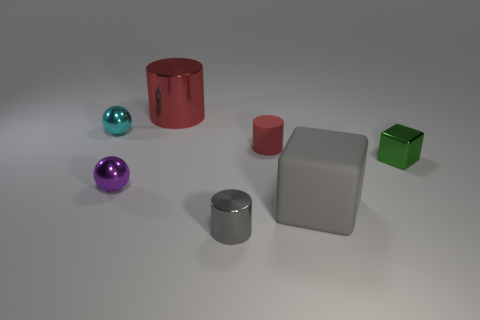There is a cube that is the same material as the small red cylinder; what size is it?
Provide a short and direct response. Large. Do the red metallic cylinder and the gray cylinder have the same size?
Your answer should be very brief. No. Are any cyan metal balls visible?
Offer a very short reply. Yes. There is another thing that is the same color as the small rubber object; what size is it?
Provide a short and direct response. Large. There is a cylinder behind the cyan shiny object that is left of the metal cylinder that is behind the green shiny cube; how big is it?
Ensure brevity in your answer.  Large. What number of small green objects have the same material as the big red object?
Ensure brevity in your answer.  1. What number of gray shiny cylinders are the same size as the cyan object?
Your response must be concise. 1. There is a large gray cube in front of the tiny cyan sphere left of the small object to the right of the large gray cube; what is its material?
Your response must be concise. Rubber. What number of objects are either purple spheres or large red objects?
Make the answer very short. 2. What shape is the tiny rubber thing?
Keep it short and to the point. Cylinder. 